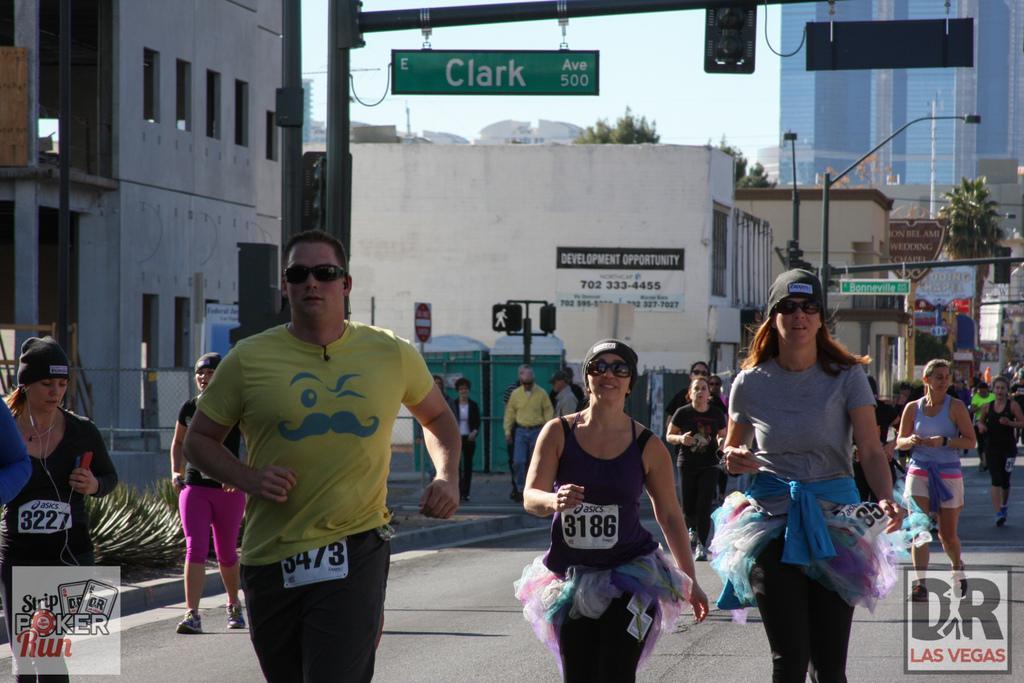Describe this image in one or two sentences. In this image in the center there are persons walking and running. In the background there are buildings, poles, trees and boards with some text written on it. 